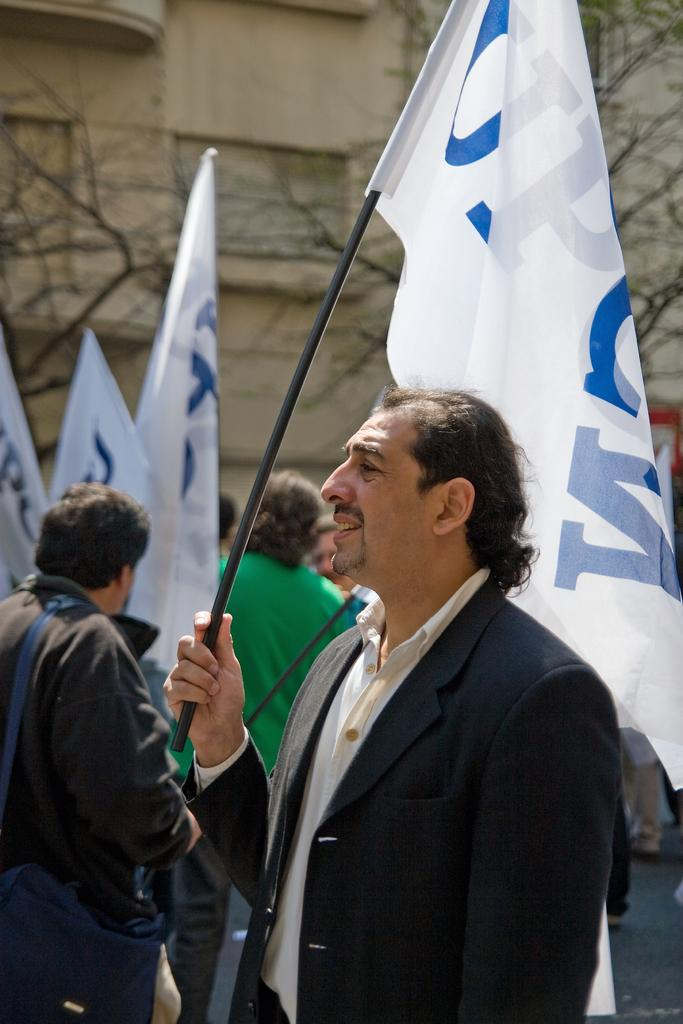What is happening in the image? There is a group of people in the image. What are the people holding? The people are holding flags. What can be seen in the background of the image? There is a building in the background of the image. What type of stamp can be seen on the flags in the image? There is no stamp present on the flags in the image; the flags are simply being held by the group of people. 